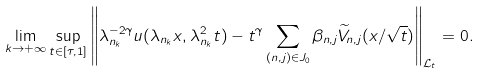<formula> <loc_0><loc_0><loc_500><loc_500>\lim _ { k \to + \infty } \sup _ { t \in [ \tau , 1 ] } \left \| \lambda _ { n _ { k } } ^ { - 2 \gamma } u ( \lambda _ { n _ { k } } x , \lambda _ { n _ { k } } ^ { 2 } t ) - t ^ { \gamma } \sum _ { ( n , j ) \in J _ { 0 } } \beta _ { n , j } \widetilde { V } _ { n , j } ( x / \sqrt { t } ) \right \| _ { { \mathcal { L } } _ { t } } = 0 .</formula> 